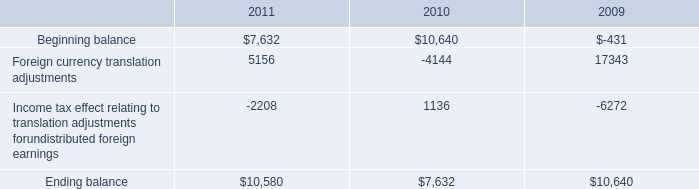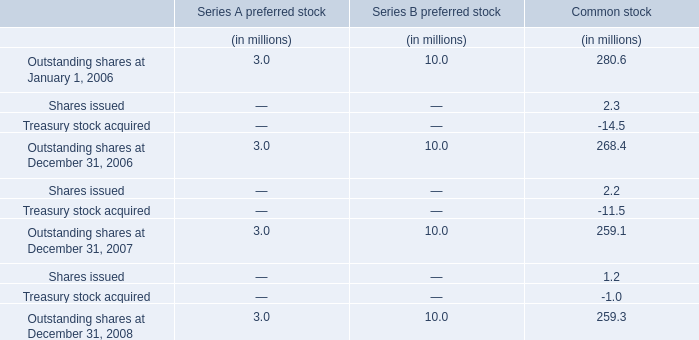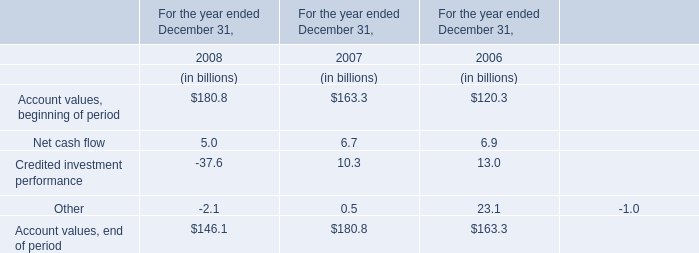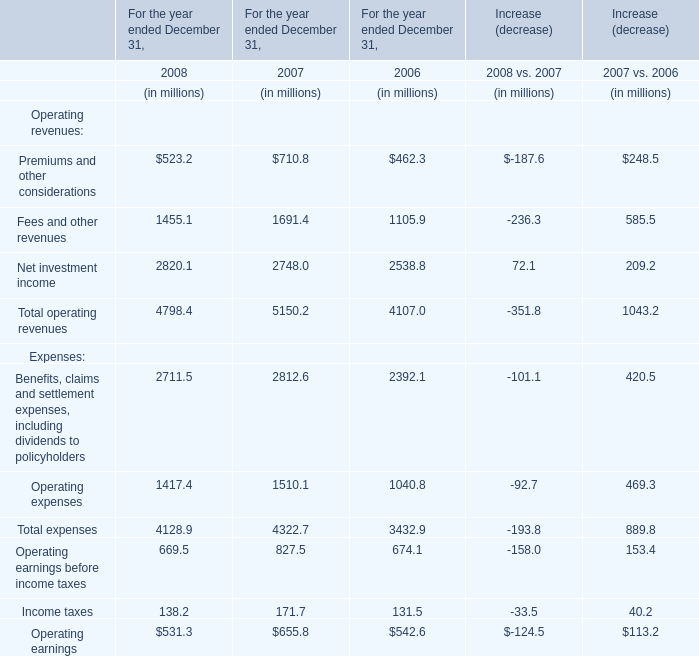In the year with lowest amount of Net cash flow, what's the increasing rate of Net cash flow? 
Computations: ((5 - 6.7) / 5)
Answer: -0.34. 